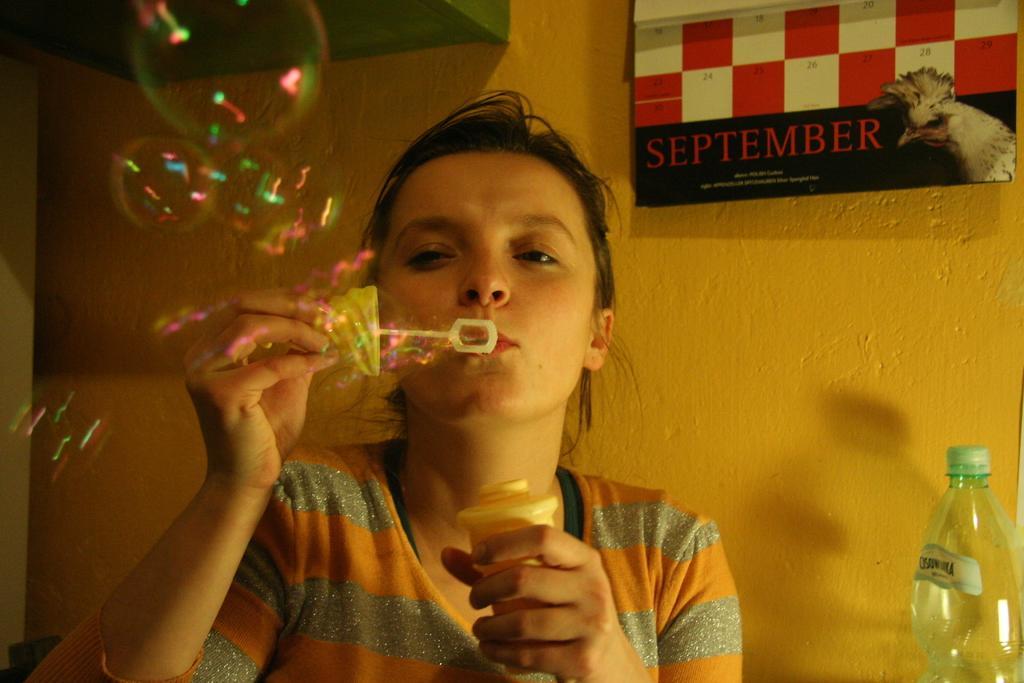How would you summarize this image in a sentence or two? As we can see in the image there is a orange color wall, bottle, banner and a woman blowing bubbles. 